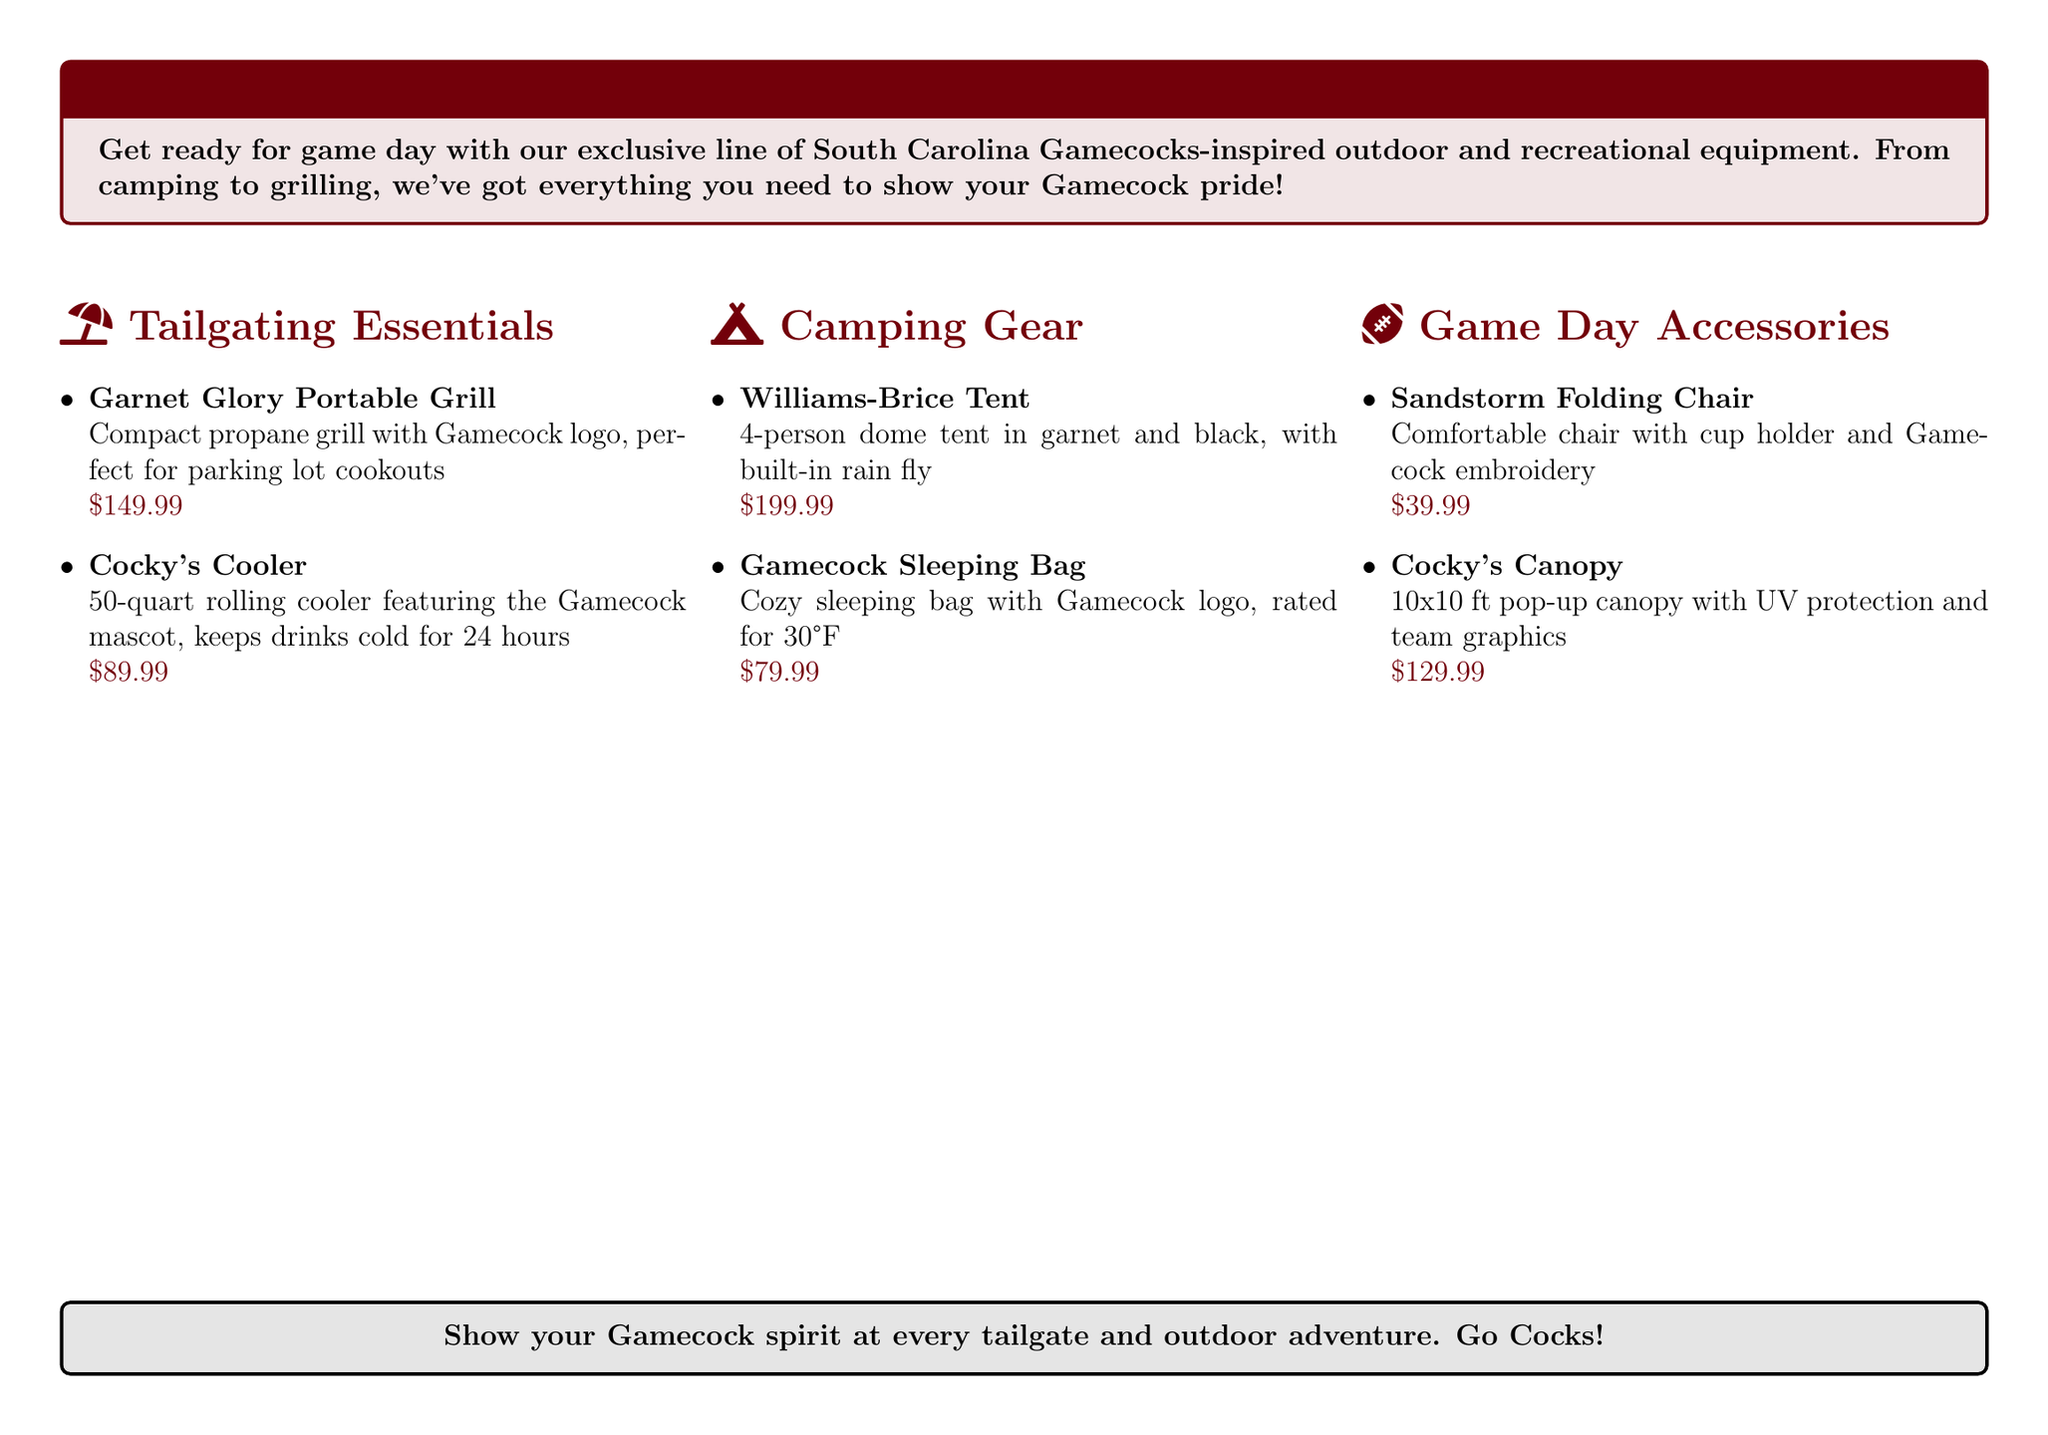What is the price of the Garnet Glory Portable Grill? The price of the Garnet Glory Portable Grill is listed in the tailgating essentials section.
Answer: $149.99 How long does Cocky's Cooler keep drinks cold? The duration is mentioned in the description of Cocky's Cooler.
Answer: 24 hours What color is the Williams-Brice Tent? The color is specified in its description under camping gear.
Answer: garnet and black What is the capacity of Cocky's Cooler? The capacity is given in quarts in the cooler's description.
Answer: 50-quart What is unique about the Sandstorm Folding Chair? The unique feature is mentioned in its brief description that highlights its comfort and design.
Answer: cup holder and Gamecock embroidery How many people can fit in the Williams-Brice Tent? The number of people is stated in the item description for the tent.
Answer: 4-person What type of protection does Cocky's Canopy offer? The type of protection is noted in the product description for the canopy.
Answer: UV protection What is the temperature rating of the Gamecock Sleeping Bag? The rating is specified in the description of the sleeping bag.
Answer: 30°F 